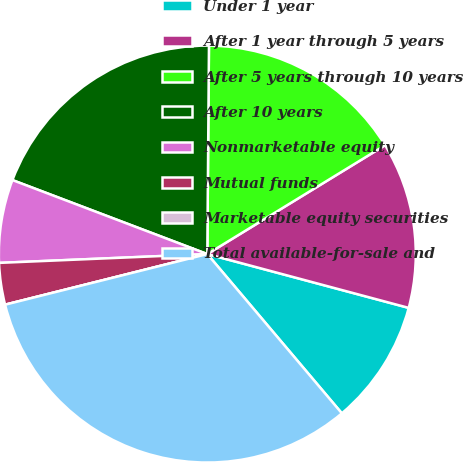Convert chart. <chart><loc_0><loc_0><loc_500><loc_500><pie_chart><fcel>Under 1 year<fcel>After 1 year through 5 years<fcel>After 5 years through 10 years<fcel>After 10 years<fcel>Nonmarketable equity<fcel>Mutual funds<fcel>Marketable equity securities<fcel>Total available-for-sale and<nl><fcel>9.68%<fcel>12.9%<fcel>16.13%<fcel>19.35%<fcel>6.45%<fcel>3.23%<fcel>0.0%<fcel>32.26%<nl></chart> 